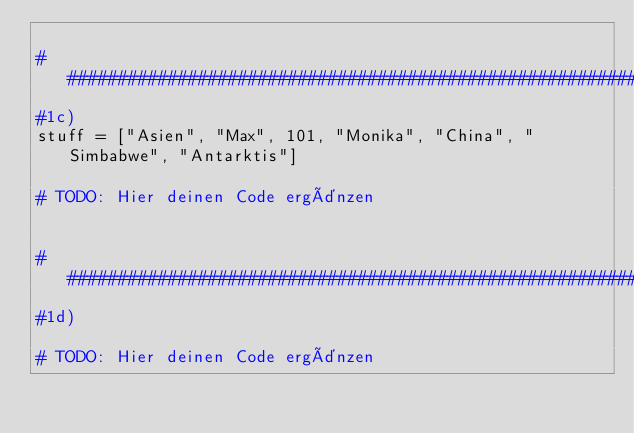Convert code to text. <code><loc_0><loc_0><loc_500><loc_500><_Python_>
########################################################################################################################
#1c)
stuff = ["Asien", "Max", 101, "Monika", "China", "Simbabwe", "Antarktis"]

# TODO: Hier deinen Code ergänzen


########################################################################################################################
#1d)

# TODO: Hier deinen Code ergänzen

</code> 